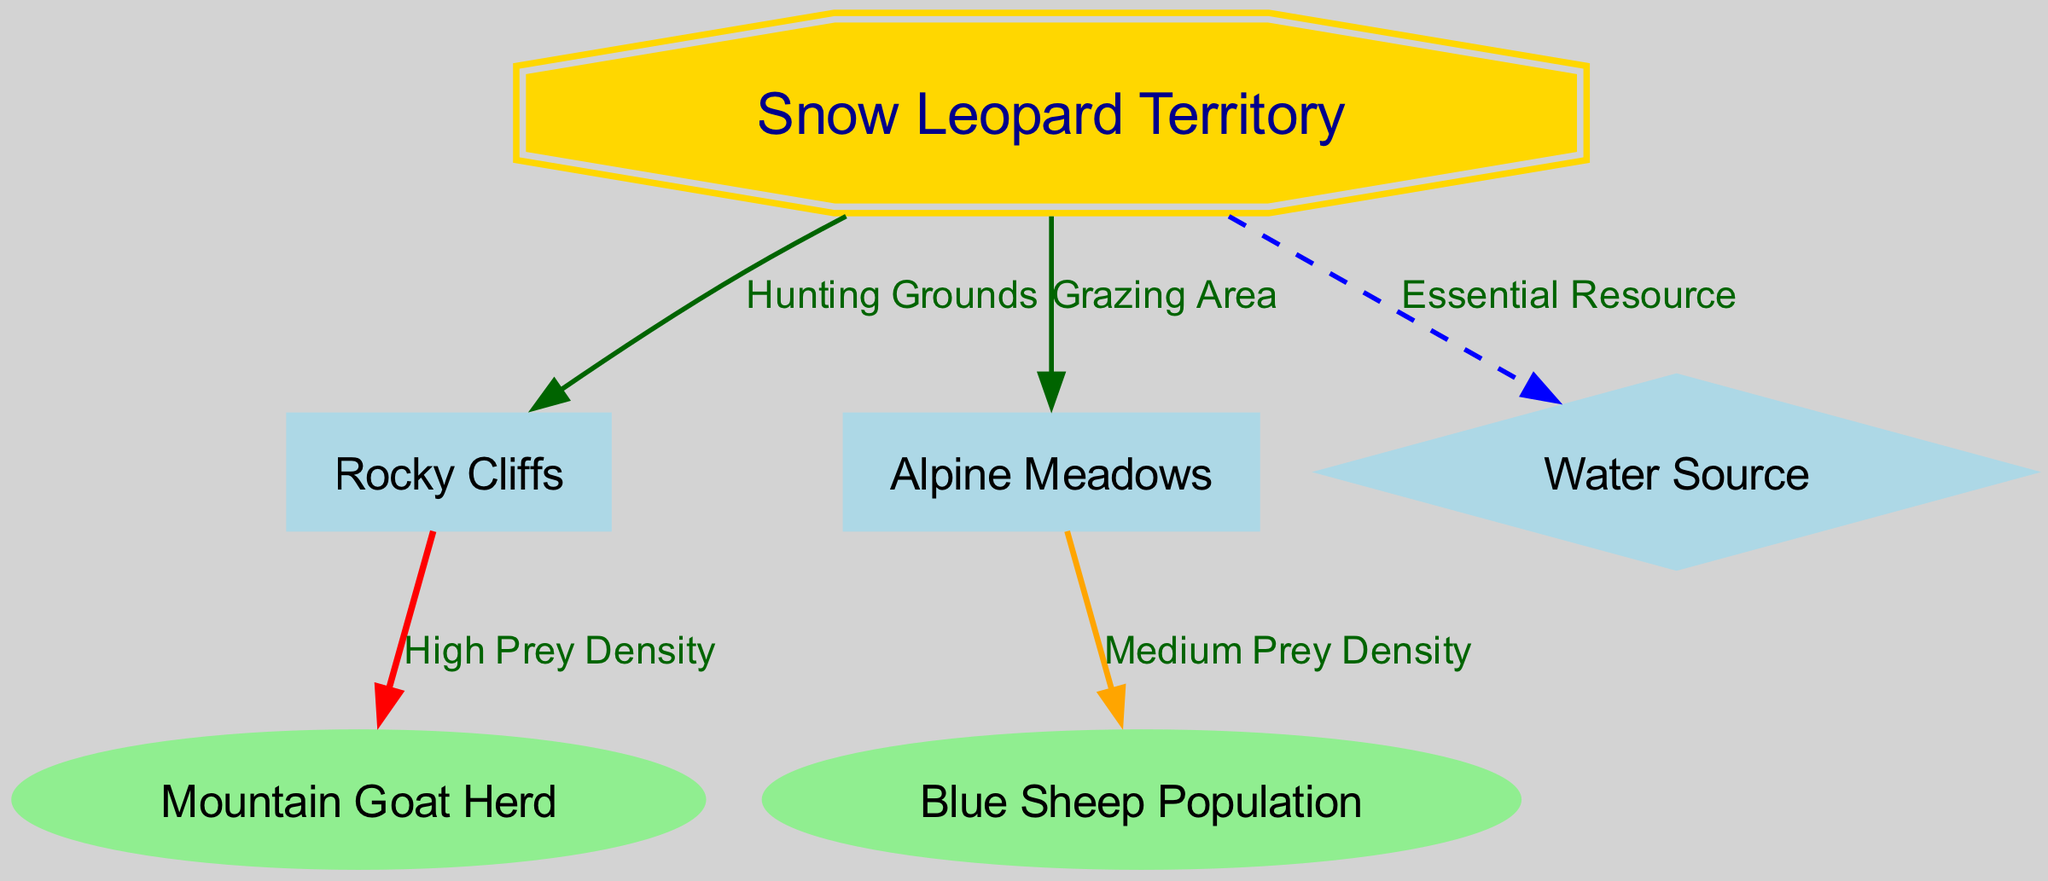What is the main hunting territory of the snow leopard? The diagram shows that the main hunting territory of the snow leopard is labeled as "Snow Leopard Territory." This node is central and connects to other important areas in its territory.
Answer: Snow Leopard Territory How many nodes represent types of prey? The diagram contains two nodes that represent types of prey: "Mountain Goat Herd" and "Blue Sheep Population." By counting these specific nodes, we arrive at the answer.
Answer: 2 What is the relationship between Rocky Cliffs and Mountain Goat Herd? The relationship is defined as "High Prey Density," indicating that the area near Rocky Cliffs has a significant population of Mountain Goats that the snow leopard hunts. This connection is evident in the edge labeled with this relationship.
Answer: High Prey Density Which node represents an essential resource for the snow leopard? The node labeled "Water Source" is represented as a diamond shape, indicating it is an essential resource for the snow leopard's territory. This node is directly connected to the main territory.
Answer: Water Source What type of landscape feature is most associated with medium prey density? The landscape feature associated with medium prey density is "Alpine Meadows." The diagram shows a medium density edge connecting the Alpine Meadows node to the Blue Sheep Population node.
Answer: Alpine Meadows Which prey has a higher density based on the diagram? The Mountain Goat Herd has a higher density compared to the Blue Sheep Population, as indicated by the edge labels. The relationship between Rocky Cliffs and Mountain Goat Herd is specifically labeled as "High Prey Density."
Answer: Mountain Goat Herd What is connected to the Snow Leopard Territory by a dashed edge? The "Water Source" is connected to the Snow Leopard Territory by a dashed edge, indicating it is an essential resource. This line is specifically formatted to denote importance.
Answer: Water Source How many total edges are in the diagram? There are a total of five edges connecting the various nodes in the diagram. By counting each of the connections displayed, we find this total.
Answer: 5 What relationship is stronger: "High Prey Density" or "Medium Prey Density"? "High Prey Density" is labeled in red in the diagram, denoting a stronger relationship compared to "Medium Prey Density," which is shown in orange. The color coding indicates that high prey areas are more significant for hunting.
Answer: High Prey Density 